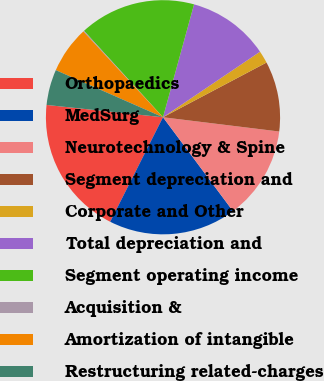Convert chart to OTSL. <chart><loc_0><loc_0><loc_500><loc_500><pie_chart><fcel>Orthopaedics<fcel>MedSurg<fcel>Neurotechnology & Spine<fcel>Segment depreciation and<fcel>Corporate and Other<fcel>Total depreciation and<fcel>Segment operating income<fcel>Acquisition &<fcel>Amortization of intangible<fcel>Restructuring related-charges<nl><fcel>19.23%<fcel>17.64%<fcel>12.86%<fcel>9.68%<fcel>1.72%<fcel>11.27%<fcel>16.05%<fcel>0.13%<fcel>6.5%<fcel>4.91%<nl></chart> 